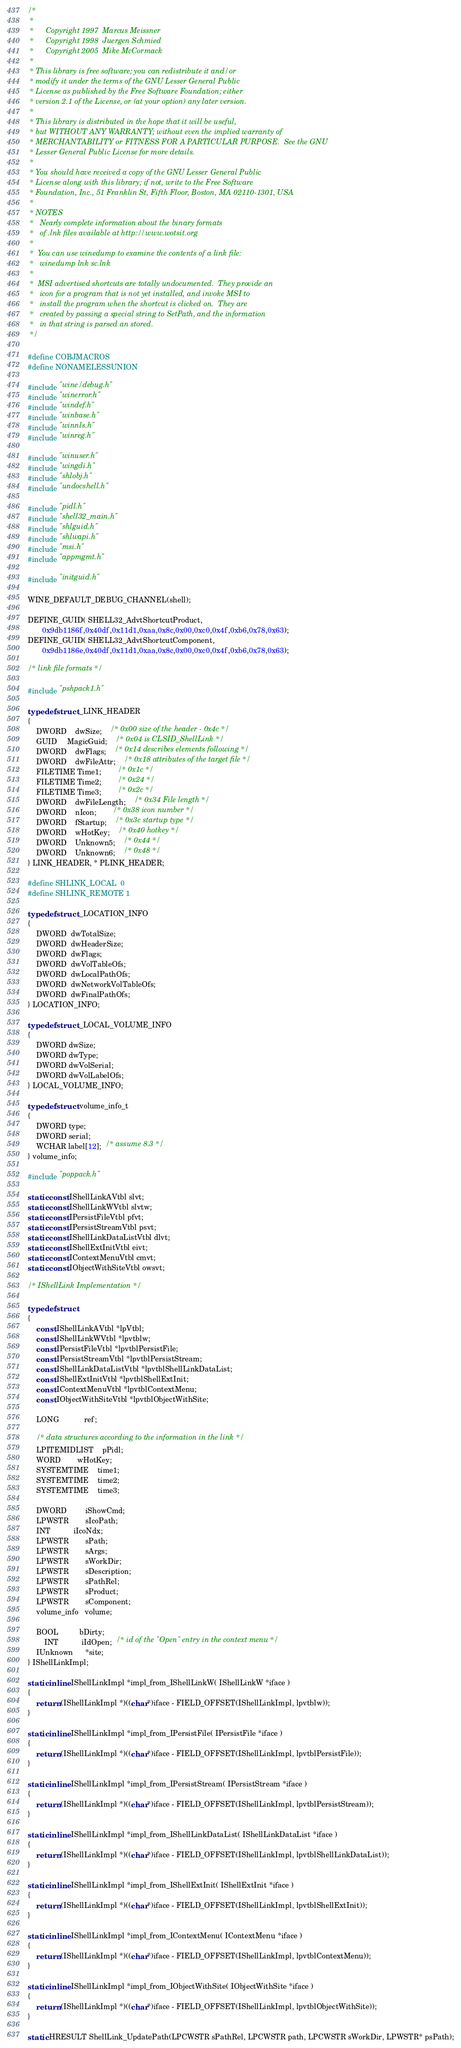Convert code to text. <code><loc_0><loc_0><loc_500><loc_500><_C_>/*
 *
 *      Copyright 1997  Marcus Meissner
 *      Copyright 1998  Juergen Schmied
 *      Copyright 2005  Mike McCormack
 *
 * This library is free software; you can redistribute it and/or
 * modify it under the terms of the GNU Lesser General Public
 * License as published by the Free Software Foundation; either
 * version 2.1 of the License, or (at your option) any later version.
 *
 * This library is distributed in the hope that it will be useful,
 * but WITHOUT ANY WARRANTY; without even the implied warranty of
 * MERCHANTABILITY or FITNESS FOR A PARTICULAR PURPOSE.  See the GNU
 * Lesser General Public License for more details.
 *
 * You should have received a copy of the GNU Lesser General Public
 * License along with this library; if not, write to the Free Software
 * Foundation, Inc., 51 Franklin St, Fifth Floor, Boston, MA 02110-1301, USA
 *
 * NOTES
 *   Nearly complete information about the binary formats
 *   of .lnk files available at http://www.wotsit.org
 *
 *  You can use winedump to examine the contents of a link file:
 *   winedump lnk sc.lnk
 *
 *  MSI advertised shortcuts are totally undocumented.  They provide an
 *   icon for a program that is not yet installed, and invoke MSI to
 *   install the program when the shortcut is clicked on.  They are
 *   created by passing a special string to SetPath, and the information
 *   in that string is parsed an stored.
 */

#define COBJMACROS
#define NONAMELESSUNION

#include "wine/debug.h"
#include "winerror.h"
#include "windef.h"
#include "winbase.h"
#include "winnls.h"
#include "winreg.h"

#include "winuser.h"
#include "wingdi.h"
#include "shlobj.h"
#include "undocshell.h"

#include "pidl.h"
#include "shell32_main.h"
#include "shlguid.h"
#include "shlwapi.h"
#include "msi.h"
#include "appmgmt.h"

#include "initguid.h"

WINE_DEFAULT_DEBUG_CHANNEL(shell);

DEFINE_GUID( SHELL32_AdvtShortcutProduct,
       0x9db1186f,0x40df,0x11d1,0xaa,0x8c,0x00,0xc0,0x4f,0xb6,0x78,0x63);
DEFINE_GUID( SHELL32_AdvtShortcutComponent,
       0x9db1186e,0x40df,0x11d1,0xaa,0x8c,0x00,0xc0,0x4f,0xb6,0x78,0x63);

/* link file formats */

#include "pshpack1.h"

typedef struct _LINK_HEADER
{
	DWORD    dwSize;	/* 0x00 size of the header - 0x4c */
	GUID     MagicGuid;	/* 0x04 is CLSID_ShellLink */
	DWORD    dwFlags;	/* 0x14 describes elements following */
	DWORD    dwFileAttr;	/* 0x18 attributes of the target file */
	FILETIME Time1;		/* 0x1c */
	FILETIME Time2;		/* 0x24 */
	FILETIME Time3;		/* 0x2c */
	DWORD    dwFileLength;	/* 0x34 File length */
	DWORD    nIcon;		/* 0x38 icon number */
	DWORD	fStartup;	/* 0x3c startup type */
	DWORD	wHotKey;	/* 0x40 hotkey */
	DWORD	Unknown5;	/* 0x44 */
	DWORD	Unknown6;	/* 0x48 */
} LINK_HEADER, * PLINK_HEADER;

#define SHLINK_LOCAL  0
#define SHLINK_REMOTE 1

typedef struct _LOCATION_INFO
{
    DWORD  dwTotalSize;
    DWORD  dwHeaderSize;
    DWORD  dwFlags;
    DWORD  dwVolTableOfs;
    DWORD  dwLocalPathOfs;
    DWORD  dwNetworkVolTableOfs;
    DWORD  dwFinalPathOfs;
} LOCATION_INFO;

typedef struct _LOCAL_VOLUME_INFO
{
    DWORD dwSize;
    DWORD dwType;
    DWORD dwVolSerial;
    DWORD dwVolLabelOfs;
} LOCAL_VOLUME_INFO;

typedef struct volume_info_t
{
    DWORD type;
    DWORD serial;
    WCHAR label[12];  /* assume 8.3 */
} volume_info;

#include "poppack.h"

static const IShellLinkAVtbl slvt;
static const IShellLinkWVtbl slvtw;
static const IPersistFileVtbl pfvt;
static const IPersistStreamVtbl psvt;
static const IShellLinkDataListVtbl dlvt;
static const IShellExtInitVtbl eivt;
static const IContextMenuVtbl cmvt;
static const IObjectWithSiteVtbl owsvt;

/* IShellLink Implementation */

typedef struct
{
	const IShellLinkAVtbl *lpVtbl;
	const IShellLinkWVtbl *lpvtblw;
	const IPersistFileVtbl *lpvtblPersistFile;
	const IPersistStreamVtbl *lpvtblPersistStream;
	const IShellLinkDataListVtbl *lpvtblShellLinkDataList;
	const IShellExtInitVtbl *lpvtblShellExtInit;
	const IContextMenuVtbl *lpvtblContextMenu;
	const IObjectWithSiteVtbl *lpvtblObjectWithSite;

	LONG            ref;

	/* data structures according to the information in the link */
	LPITEMIDLIST	pPidl;
	WORD		wHotKey;
	SYSTEMTIME	time1;
	SYSTEMTIME	time2;
	SYSTEMTIME	time3;

	DWORD         iShowCmd;
	LPWSTR        sIcoPath;
	INT           iIcoNdx;
	LPWSTR        sPath;
	LPWSTR        sArgs;
	LPWSTR        sWorkDir;
	LPWSTR        sDescription;
	LPWSTR        sPathRel;
 	LPWSTR        sProduct;
 	LPWSTR        sComponent;
	volume_info   volume;

	BOOL          bDirty;
        INT           iIdOpen;  /* id of the "Open" entry in the context menu */
	IUnknown      *site;
} IShellLinkImpl;

static inline IShellLinkImpl *impl_from_IShellLinkW( IShellLinkW *iface )
{
    return (IShellLinkImpl *)((char*)iface - FIELD_OFFSET(IShellLinkImpl, lpvtblw));
}

static inline IShellLinkImpl *impl_from_IPersistFile( IPersistFile *iface )
{
    return (IShellLinkImpl *)((char*)iface - FIELD_OFFSET(IShellLinkImpl, lpvtblPersistFile));
}

static inline IShellLinkImpl *impl_from_IPersistStream( IPersistStream *iface )
{
    return (IShellLinkImpl *)((char*)iface - FIELD_OFFSET(IShellLinkImpl, lpvtblPersistStream));
}

static inline IShellLinkImpl *impl_from_IShellLinkDataList( IShellLinkDataList *iface )
{
    return (IShellLinkImpl *)((char*)iface - FIELD_OFFSET(IShellLinkImpl, lpvtblShellLinkDataList));
}

static inline IShellLinkImpl *impl_from_IShellExtInit( IShellExtInit *iface )
{
    return (IShellLinkImpl *)((char*)iface - FIELD_OFFSET(IShellLinkImpl, lpvtblShellExtInit));
}

static inline IShellLinkImpl *impl_from_IContextMenu( IContextMenu *iface )
{
    return (IShellLinkImpl *)((char*)iface - FIELD_OFFSET(IShellLinkImpl, lpvtblContextMenu));
}

static inline IShellLinkImpl *impl_from_IObjectWithSite( IObjectWithSite *iface )
{
    return (IShellLinkImpl *)((char*)iface - FIELD_OFFSET(IShellLinkImpl, lpvtblObjectWithSite));
}

static HRESULT ShellLink_UpdatePath(LPCWSTR sPathRel, LPCWSTR path, LPCWSTR sWorkDir, LPWSTR* psPath);
</code> 